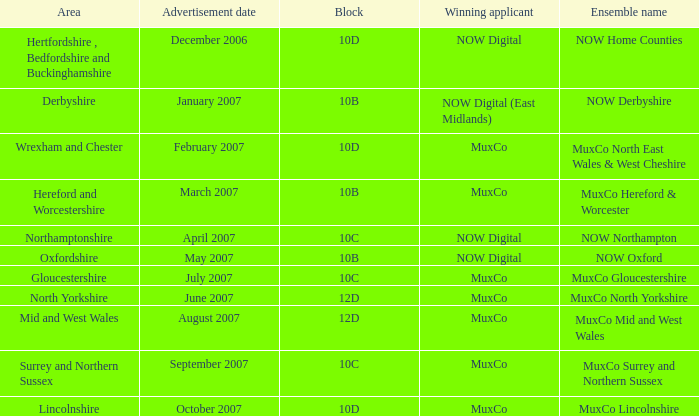What is the promotion date for ensemble name muxco gloucestershire in block 10c? July 2007. 